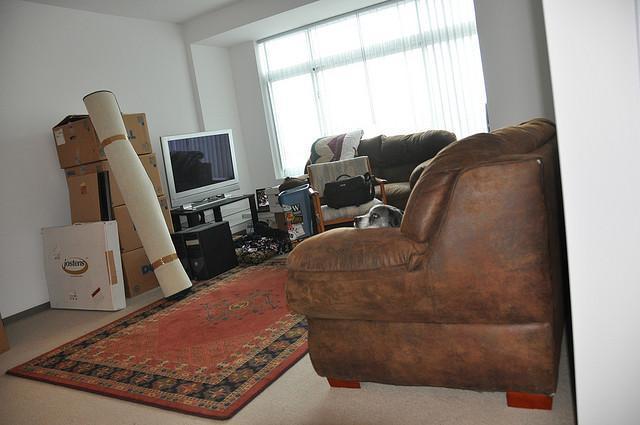How many couches are there?
Give a very brief answer. 2. How many chairs are visible?
Give a very brief answer. 2. How many tvs are in the photo?
Give a very brief answer. 1. How many people total are in the picture?
Give a very brief answer. 0. 